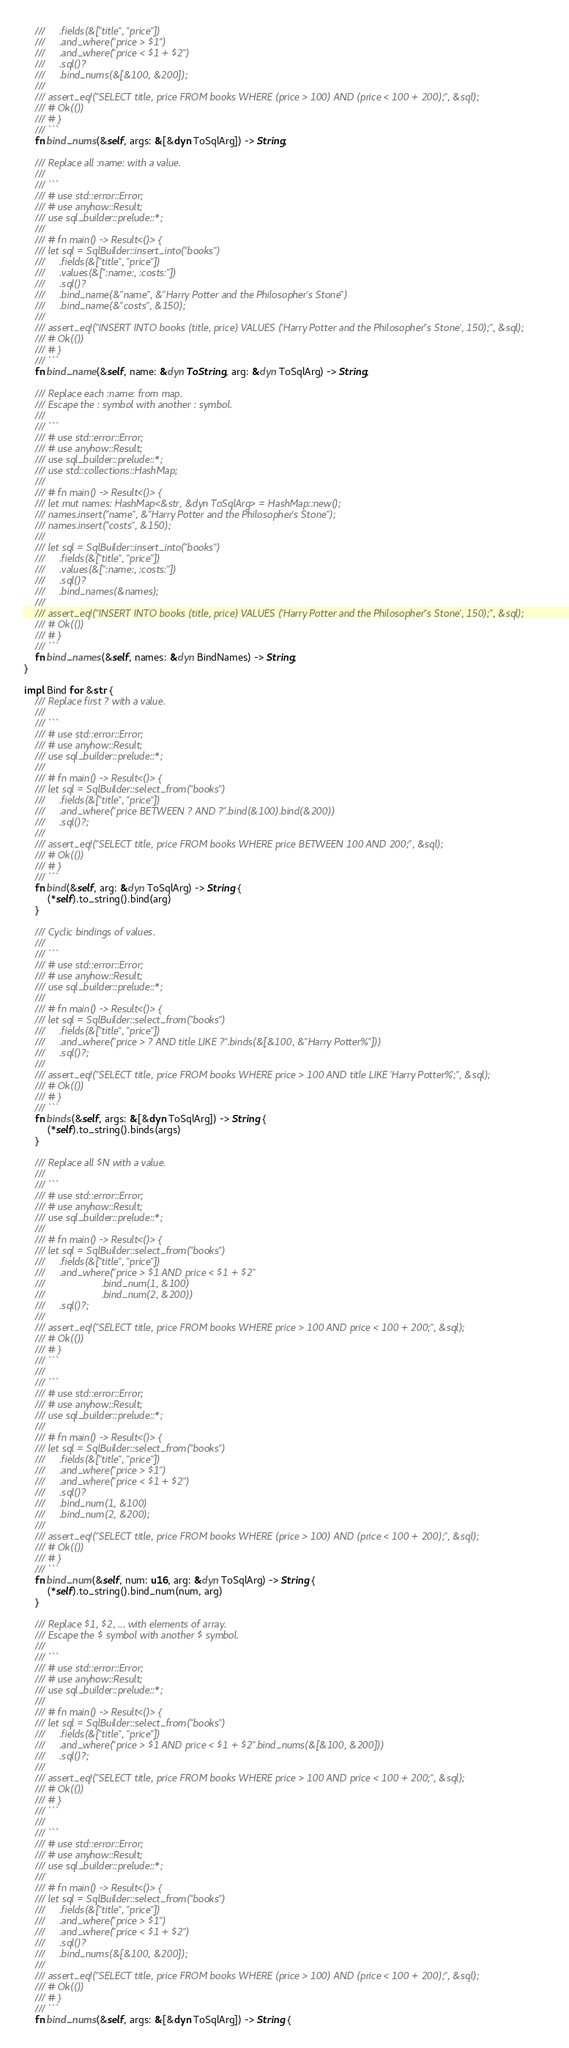<code> <loc_0><loc_0><loc_500><loc_500><_Rust_>    ///     .fields(&["title", "price"])
    ///     .and_where("price > $1")
    ///     .and_where("price < $1 + $2")
    ///     .sql()?
    ///     .bind_nums(&[&100, &200]);
    ///
    /// assert_eq!("SELECT title, price FROM books WHERE (price > 100) AND (price < 100 + 200);", &sql);
    /// # Ok(())
    /// # }
    /// ```
    fn bind_nums(&self, args: &[&dyn ToSqlArg]) -> String;

    /// Replace all :name: with a value.
    ///
    /// ```
    /// # use std::error::Error;
    /// # use anyhow::Result;
    /// use sql_builder::prelude::*;
    ///
    /// # fn main() -> Result<()> {
    /// let sql = SqlBuilder::insert_into("books")
    ///     .fields(&["title", "price"])
    ///     .values(&[":name:, :costs:"])
    ///     .sql()?
    ///     .bind_name(&"name", &"Harry Potter and the Philosopher's Stone")
    ///     .bind_name(&"costs", &150);
    ///
    /// assert_eq!("INSERT INTO books (title, price) VALUES ('Harry Potter and the Philosopher''s Stone', 150);", &sql);
    /// # Ok(())
    /// # }
    /// ```
    fn bind_name(&self, name: &dyn ToString, arg: &dyn ToSqlArg) -> String;

    /// Replace each :name: from map.
    /// Escape the : symbol with another : symbol.
    ///
    /// ```
    /// # use std::error::Error;
    /// # use anyhow::Result;
    /// use sql_builder::prelude::*;
    /// use std::collections::HashMap;
    ///
    /// # fn main() -> Result<()> {
    /// let mut names: HashMap<&str, &dyn ToSqlArg> = HashMap::new();
    /// names.insert("name", &"Harry Potter and the Philosopher's Stone");
    /// names.insert("costs", &150);
    ///
    /// let sql = SqlBuilder::insert_into("books")
    ///     .fields(&["title", "price"])
    ///     .values(&[":name:, :costs:"])
    ///     .sql()?
    ///     .bind_names(&names);
    ///
    /// assert_eq!("INSERT INTO books (title, price) VALUES ('Harry Potter and the Philosopher''s Stone', 150);", &sql);
    /// # Ok(())
    /// # }
    /// ```
    fn bind_names(&self, names: &dyn BindNames) -> String;
}

impl Bind for &str {
    /// Replace first ? with a value.
    ///
    /// ```
    /// # use std::error::Error;
    /// # use anyhow::Result;
    /// use sql_builder::prelude::*;
    ///
    /// # fn main() -> Result<()> {
    /// let sql = SqlBuilder::select_from("books")
    ///     .fields(&["title", "price"])
    ///     .and_where("price BETWEEN ? AND ?".bind(&100).bind(&200))
    ///     .sql()?;
    ///
    /// assert_eq!("SELECT title, price FROM books WHERE price BETWEEN 100 AND 200;", &sql);
    /// # Ok(())
    /// # }
    /// ```
    fn bind(&self, arg: &dyn ToSqlArg) -> String {
        (*self).to_string().bind(arg)
    }

    /// Cyclic bindings of values.
    ///
    /// ```
    /// # use std::error::Error;
    /// # use anyhow::Result;
    /// use sql_builder::prelude::*;
    ///
    /// # fn main() -> Result<()> {
    /// let sql = SqlBuilder::select_from("books")
    ///     .fields(&["title", "price"])
    ///     .and_where("price > ? AND title LIKE ?".binds(&[&100, &"Harry Potter%"]))
    ///     .sql()?;
    ///
    /// assert_eq!("SELECT title, price FROM books WHERE price > 100 AND title LIKE 'Harry Potter%';", &sql);
    /// # Ok(())
    /// # }
    /// ```
    fn binds(&self, args: &[&dyn ToSqlArg]) -> String {
        (*self).to_string().binds(args)
    }

    /// Replace all $N with a value.
    ///
    /// ```
    /// # use std::error::Error;
    /// # use anyhow::Result;
    /// use sql_builder::prelude::*;
    ///
    /// # fn main() -> Result<()> {
    /// let sql = SqlBuilder::select_from("books")
    ///     .fields(&["title", "price"])
    ///     .and_where("price > $1 AND price < $1 + $2"
    ///                    .bind_num(1, &100)
    ///                    .bind_num(2, &200))
    ///     .sql()?;
    ///
    /// assert_eq!("SELECT title, price FROM books WHERE price > 100 AND price < 100 + 200;", &sql);
    /// # Ok(())
    /// # }
    /// ```
    ///
    /// ```
    /// # use std::error::Error;
    /// # use anyhow::Result;
    /// use sql_builder::prelude::*;
    ///
    /// # fn main() -> Result<()> {
    /// let sql = SqlBuilder::select_from("books")
    ///     .fields(&["title", "price"])
    ///     .and_where("price > $1")
    ///     .and_where("price < $1 + $2")
    ///     .sql()?
    ///     .bind_num(1, &100)
    ///     .bind_num(2, &200);
    ///
    /// assert_eq!("SELECT title, price FROM books WHERE (price > 100) AND (price < 100 + 200);", &sql);
    /// # Ok(())
    /// # }
    /// ```
    fn bind_num(&self, num: u16, arg: &dyn ToSqlArg) -> String {
        (*self).to_string().bind_num(num, arg)
    }

    /// Replace $1, $2, ... with elements of array.
    /// Escape the $ symbol with another $ symbol.
    ///
    /// ```
    /// # use std::error::Error;
    /// # use anyhow::Result;
    /// use sql_builder::prelude::*;
    ///
    /// # fn main() -> Result<()> {
    /// let sql = SqlBuilder::select_from("books")
    ///     .fields(&["title", "price"])
    ///     .and_where("price > $1 AND price < $1 + $2".bind_nums(&[&100, &200]))
    ///     .sql()?;
    ///
    /// assert_eq!("SELECT title, price FROM books WHERE price > 100 AND price < 100 + 200;", &sql);
    /// # Ok(())
    /// # }
    /// ```
    ///
    /// ```
    /// # use std::error::Error;
    /// # use anyhow::Result;
    /// use sql_builder::prelude::*;
    ///
    /// # fn main() -> Result<()> {
    /// let sql = SqlBuilder::select_from("books")
    ///     .fields(&["title", "price"])
    ///     .and_where("price > $1")
    ///     .and_where("price < $1 + $2")
    ///     .sql()?
    ///     .bind_nums(&[&100, &200]);
    ///
    /// assert_eq!("SELECT title, price FROM books WHERE (price > 100) AND (price < 100 + 200);", &sql);
    /// # Ok(())
    /// # }
    /// ```
    fn bind_nums(&self, args: &[&dyn ToSqlArg]) -> String {</code> 